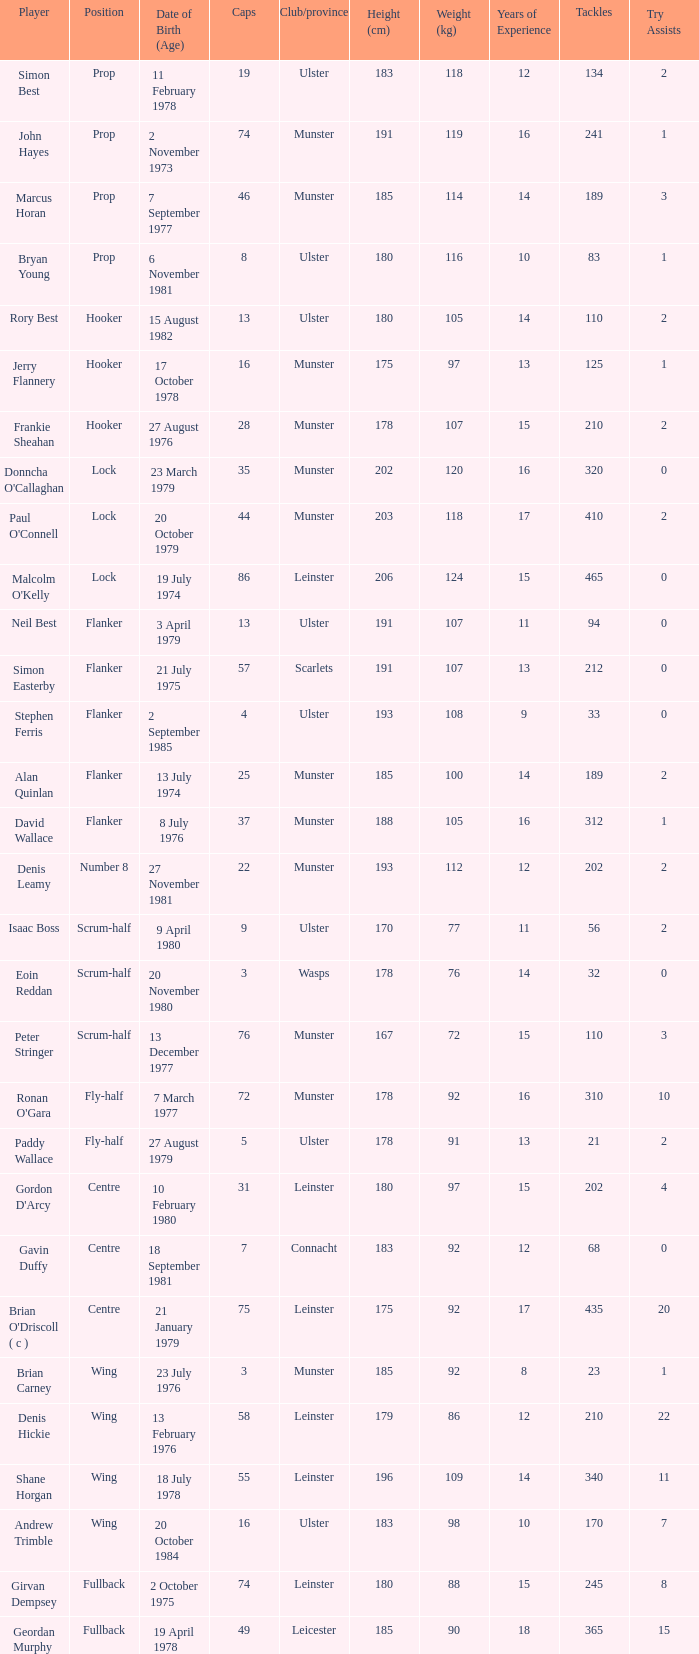Which Ulster player has fewer than 49 caps and plays the wing position? Andrew Trimble. 